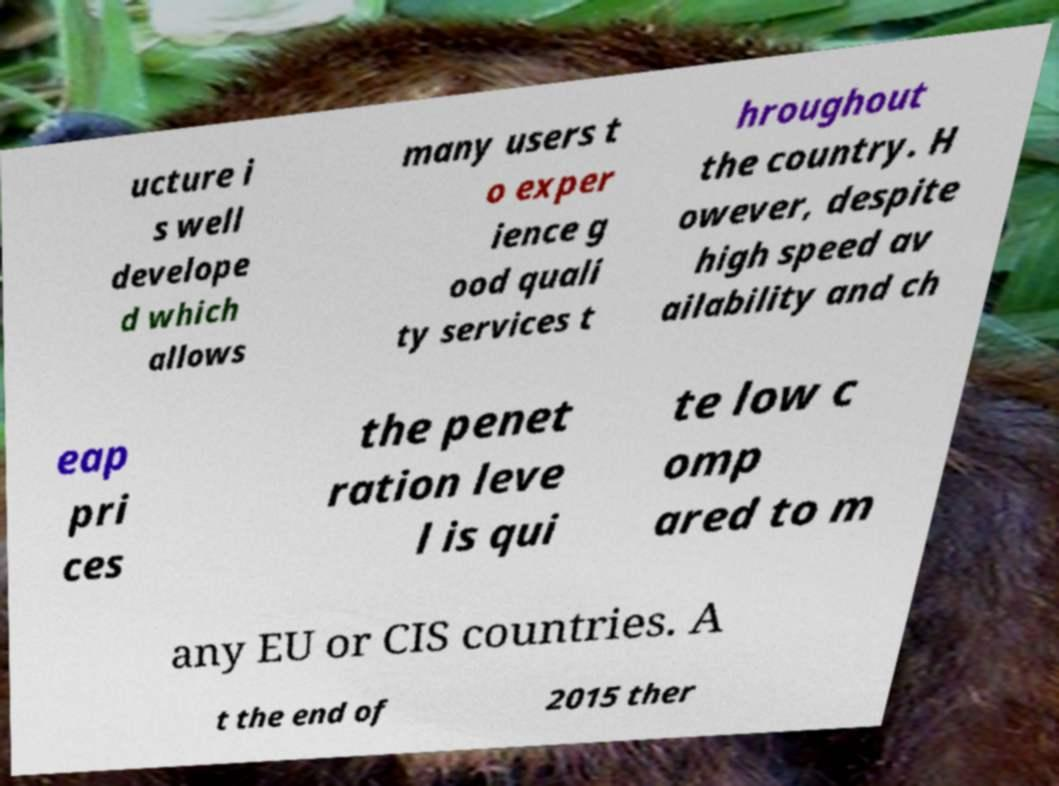Please identify and transcribe the text found in this image. ucture i s well develope d which allows many users t o exper ience g ood quali ty services t hroughout the country. H owever, despite high speed av ailability and ch eap pri ces the penet ration leve l is qui te low c omp ared to m any EU or CIS countries. A t the end of 2015 ther 